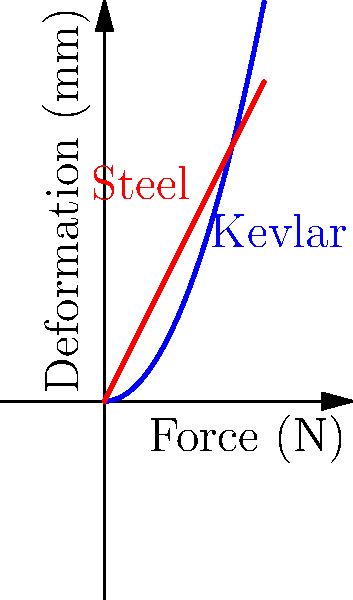As a campus security officer, you're evaluating different materials for protective gear. The graph shows the force-deformation relationship for Kevlar and steel plates of equal thickness. Based on the graph, which material would be more effective in absorbing impact energy from a high-speed projectile, and why? To determine which material is more effective in absorbing impact energy, we need to analyze the force-deformation curves:

1. The area under each curve represents the energy absorbed by the material.

2. Kevlar's curve (blue) is nonlinear and steeper, while steel's curve (red) is linear.

3. For the same maximum force, Kevlar deforms more than steel:
   - At 5N force, Kevlar deforms by about $\sqrt{10} \approx 3.16$ mm
   - At 5N force, steel deforms by $5/2 = 2.5$ mm

4. More deformation means more energy absorption:
   - Energy absorbed = $\int_{0}^{F} f(x) dx$, where $f(x)$ is the force-deformation function
   - Kevlar's area under the curve is larger than steel's for the same maximum force

5. Kevlar's nonlinear behavior allows it to:
   - Deform more easily at low forces (initial impact)
   - Stiffen progressively as force increases (spreading the impact over time)

6. This progressive stiffening helps distribute the impact force over a longer time, reducing peak acceleration and the risk of injury.

Therefore, Kevlar would be more effective in absorbing impact energy from a high-speed projectile due to its greater deformation and nonlinear force-deformation relationship.
Answer: Kevlar, due to greater energy absorption and progressive stiffening. 